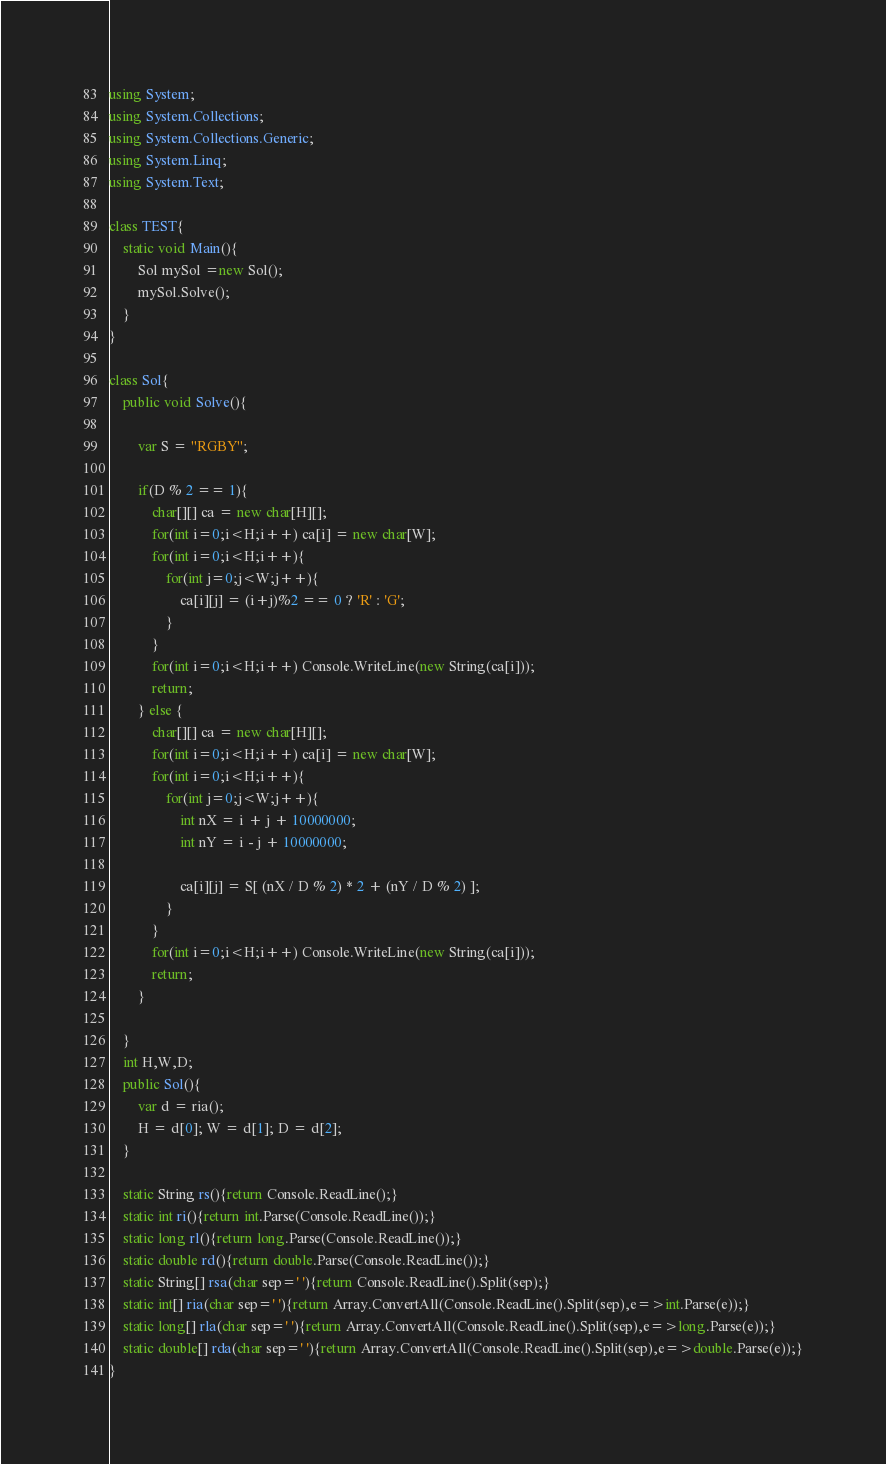Convert code to text. <code><loc_0><loc_0><loc_500><loc_500><_C#_>using System;
using System.Collections;
using System.Collections.Generic;
using System.Linq;
using System.Text;

class TEST{
	static void Main(){
		Sol mySol =new Sol();
		mySol.Solve();
	}
}

class Sol{
	public void Solve(){
		
		var S = "RGBY";
		
		if(D % 2 == 1){
			char[][] ca = new char[H][];
			for(int i=0;i<H;i++) ca[i] = new char[W];
			for(int i=0;i<H;i++){
				for(int j=0;j<W;j++){
					ca[i][j] = (i+j)%2 == 0 ? 'R' : 'G';
				}
			}
			for(int i=0;i<H;i++) Console.WriteLine(new String(ca[i]));
			return;
		} else {
			char[][] ca = new char[H][];
			for(int i=0;i<H;i++) ca[i] = new char[W];
			for(int i=0;i<H;i++){
				for(int j=0;j<W;j++){
					int nX = i + j + 10000000;
					int nY = i - j + 10000000;
					
					ca[i][j] = S[ (nX / D % 2) * 2 + (nY / D % 2) ];
				}
			}
			for(int i=0;i<H;i++) Console.WriteLine(new String(ca[i]));
			return;
		}
		
	}
	int H,W,D;
	public Sol(){
		var d = ria();
		H = d[0]; W = d[1]; D = d[2];
	}

	static String rs(){return Console.ReadLine();}
	static int ri(){return int.Parse(Console.ReadLine());}
	static long rl(){return long.Parse(Console.ReadLine());}
	static double rd(){return double.Parse(Console.ReadLine());}
	static String[] rsa(char sep=' '){return Console.ReadLine().Split(sep);}
	static int[] ria(char sep=' '){return Array.ConvertAll(Console.ReadLine().Split(sep),e=>int.Parse(e));}
	static long[] rla(char sep=' '){return Array.ConvertAll(Console.ReadLine().Split(sep),e=>long.Parse(e));}
	static double[] rda(char sep=' '){return Array.ConvertAll(Console.ReadLine().Split(sep),e=>double.Parse(e));}
}
</code> 